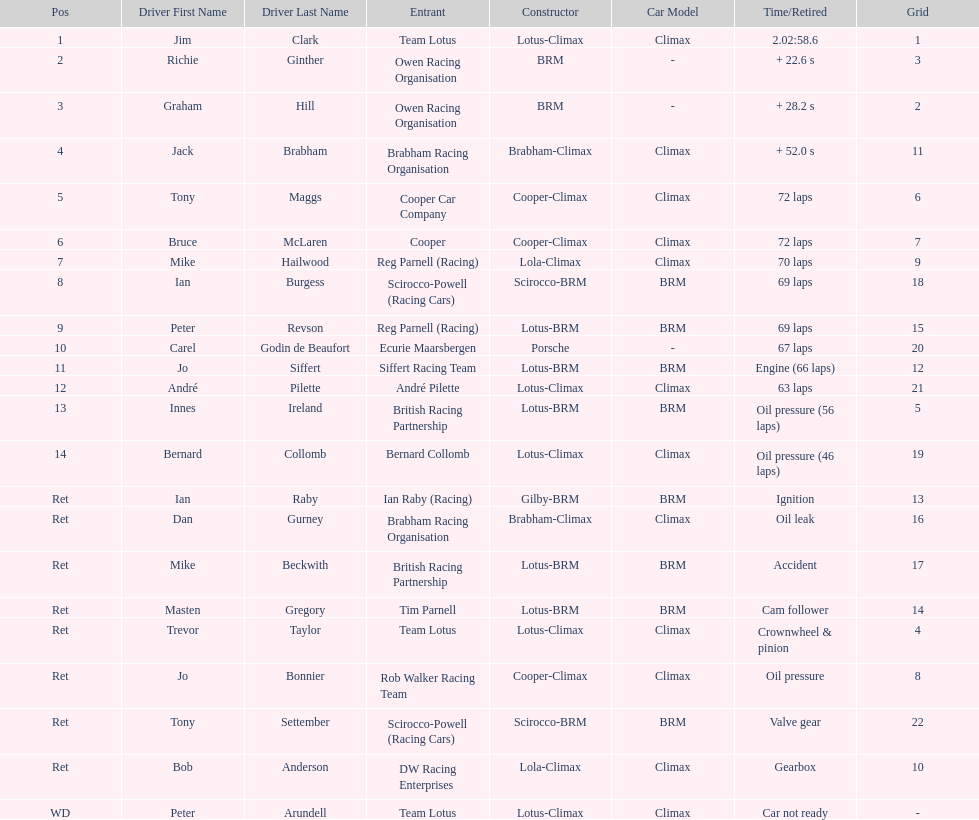How many racers had cooper-climax as their constructor? 3. 